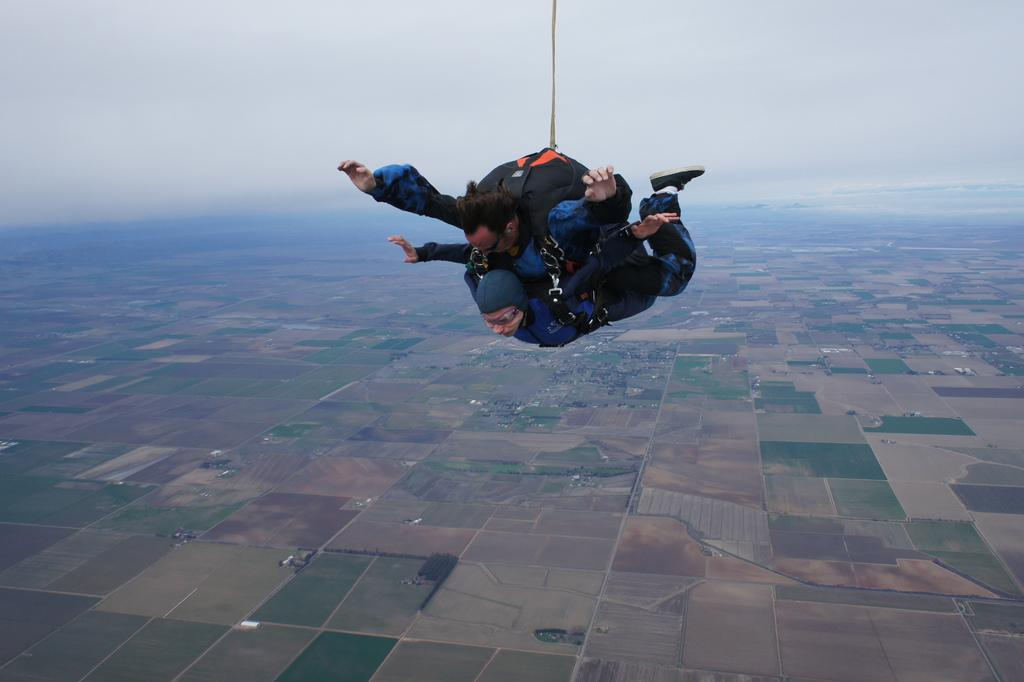How many people are in the image? There are two persons in the image. Where are the persons located in the image? The persons are in the air. What can be seen below the persons in the image? The ground is visible in the image. What is visible in the background of the image? The sky is visible in the background of the image. What type of sweater is the person wearing in the image? There is no sweater visible in the image, as the persons are in the air and not wearing any clothing. What are the persons doing for rest in the image? The persons are not resting in the image; they are in the air. 